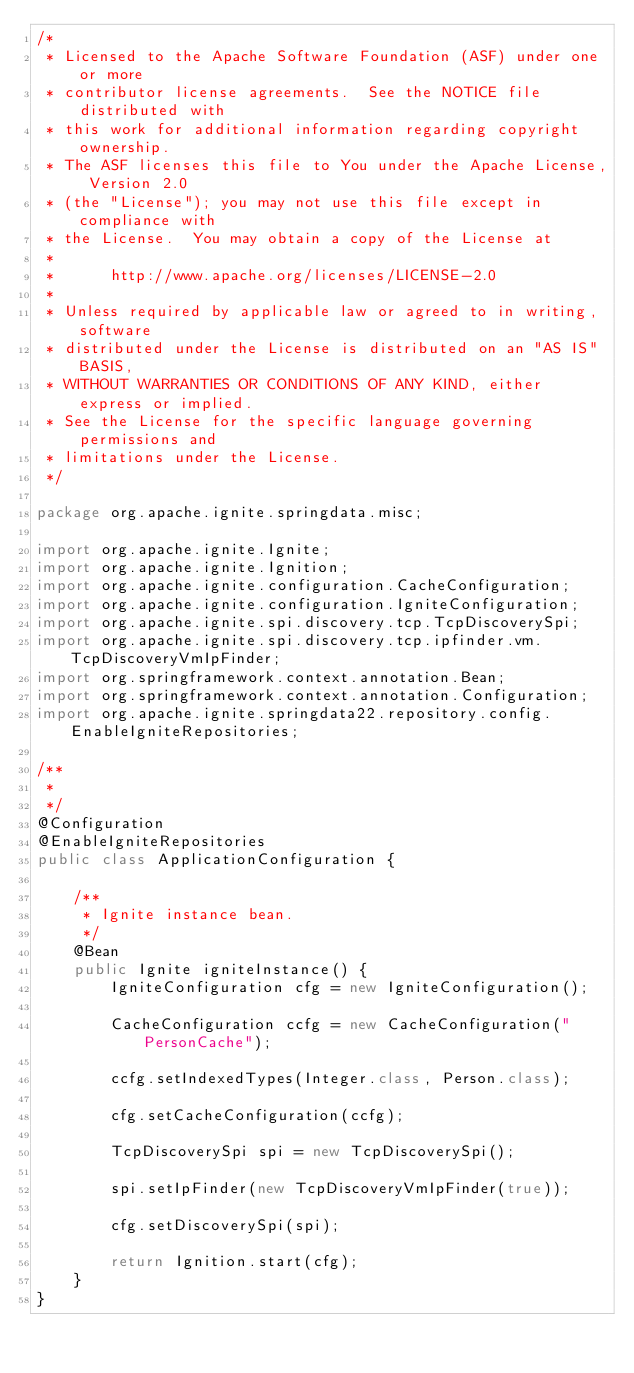Convert code to text. <code><loc_0><loc_0><loc_500><loc_500><_Java_>/*
 * Licensed to the Apache Software Foundation (ASF) under one or more
 * contributor license agreements.  See the NOTICE file distributed with
 * this work for additional information regarding copyright ownership.
 * The ASF licenses this file to You under the Apache License, Version 2.0
 * (the "License"); you may not use this file except in compliance with
 * the License.  You may obtain a copy of the License at
 *
 *      http://www.apache.org/licenses/LICENSE-2.0
 *
 * Unless required by applicable law or agreed to in writing, software
 * distributed under the License is distributed on an "AS IS" BASIS,
 * WITHOUT WARRANTIES OR CONDITIONS OF ANY KIND, either express or implied.
 * See the License for the specific language governing permissions and
 * limitations under the License.
 */

package org.apache.ignite.springdata.misc;

import org.apache.ignite.Ignite;
import org.apache.ignite.Ignition;
import org.apache.ignite.configuration.CacheConfiguration;
import org.apache.ignite.configuration.IgniteConfiguration;
import org.apache.ignite.spi.discovery.tcp.TcpDiscoverySpi;
import org.apache.ignite.spi.discovery.tcp.ipfinder.vm.TcpDiscoveryVmIpFinder;
import org.springframework.context.annotation.Bean;
import org.springframework.context.annotation.Configuration;
import org.apache.ignite.springdata22.repository.config.EnableIgniteRepositories;

/**
 *
 */
@Configuration
@EnableIgniteRepositories
public class ApplicationConfiguration {

    /**
     * Ignite instance bean.
     */
    @Bean
    public Ignite igniteInstance() {
        IgniteConfiguration cfg = new IgniteConfiguration();

        CacheConfiguration ccfg = new CacheConfiguration("PersonCache");

        ccfg.setIndexedTypes(Integer.class, Person.class);

        cfg.setCacheConfiguration(ccfg);

        TcpDiscoverySpi spi = new TcpDiscoverySpi();

        spi.setIpFinder(new TcpDiscoveryVmIpFinder(true));

        cfg.setDiscoverySpi(spi);

        return Ignition.start(cfg);
    }
}
</code> 